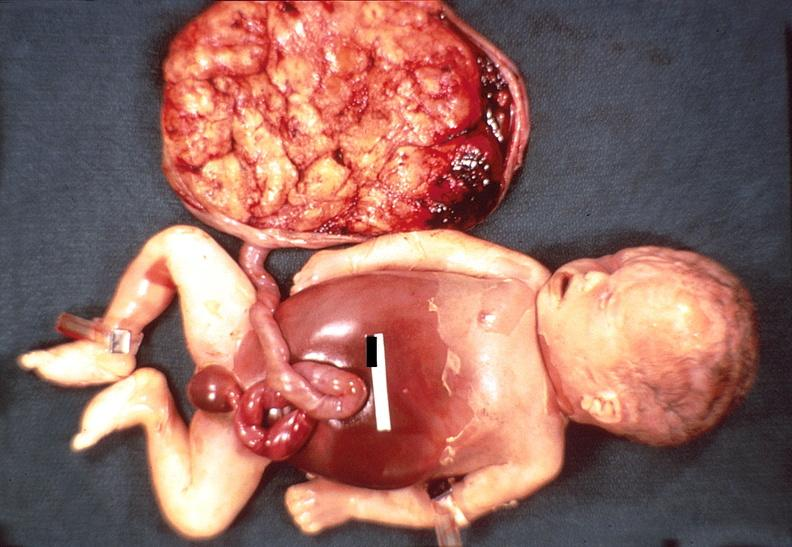does this image show hemolytic disease of newborn?
Answer the question using a single word or phrase. Yes 